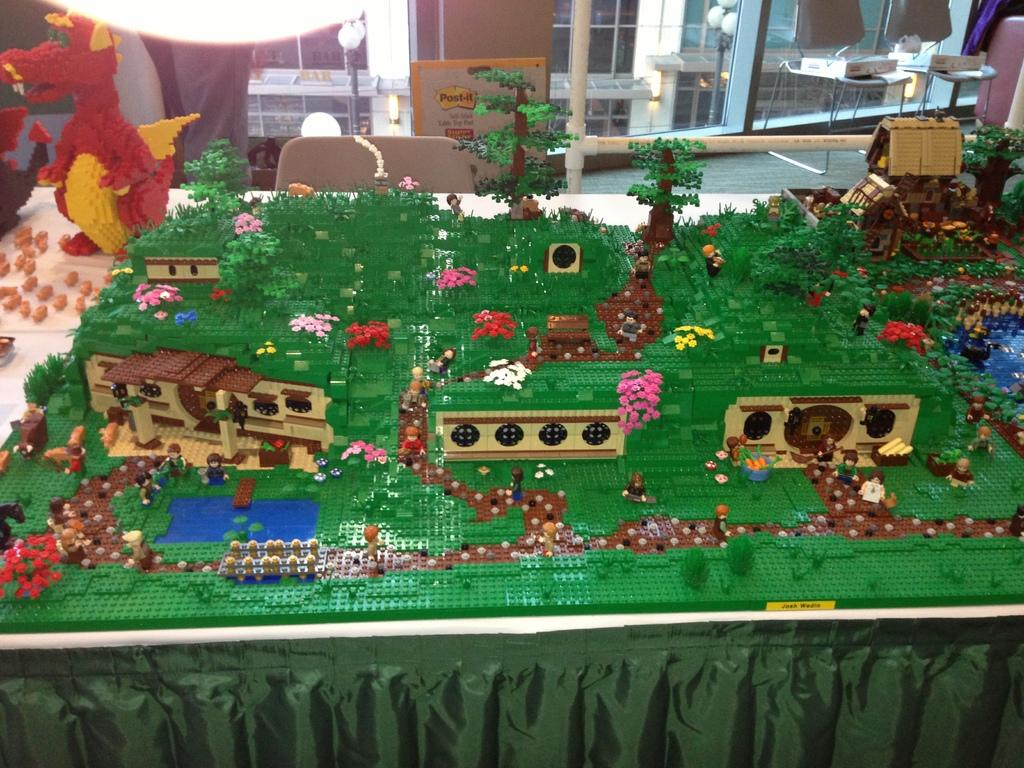What type of toys are featured in the image? There are Lego sets in the image. What can be seen in the background of the image? There are chairs, lights, and a building in the background of the image. How many fingers are visible on the Lego figures in the image? There are no fingers visible on the Lego figures in the image, as Lego figures do not have individual fingers. 